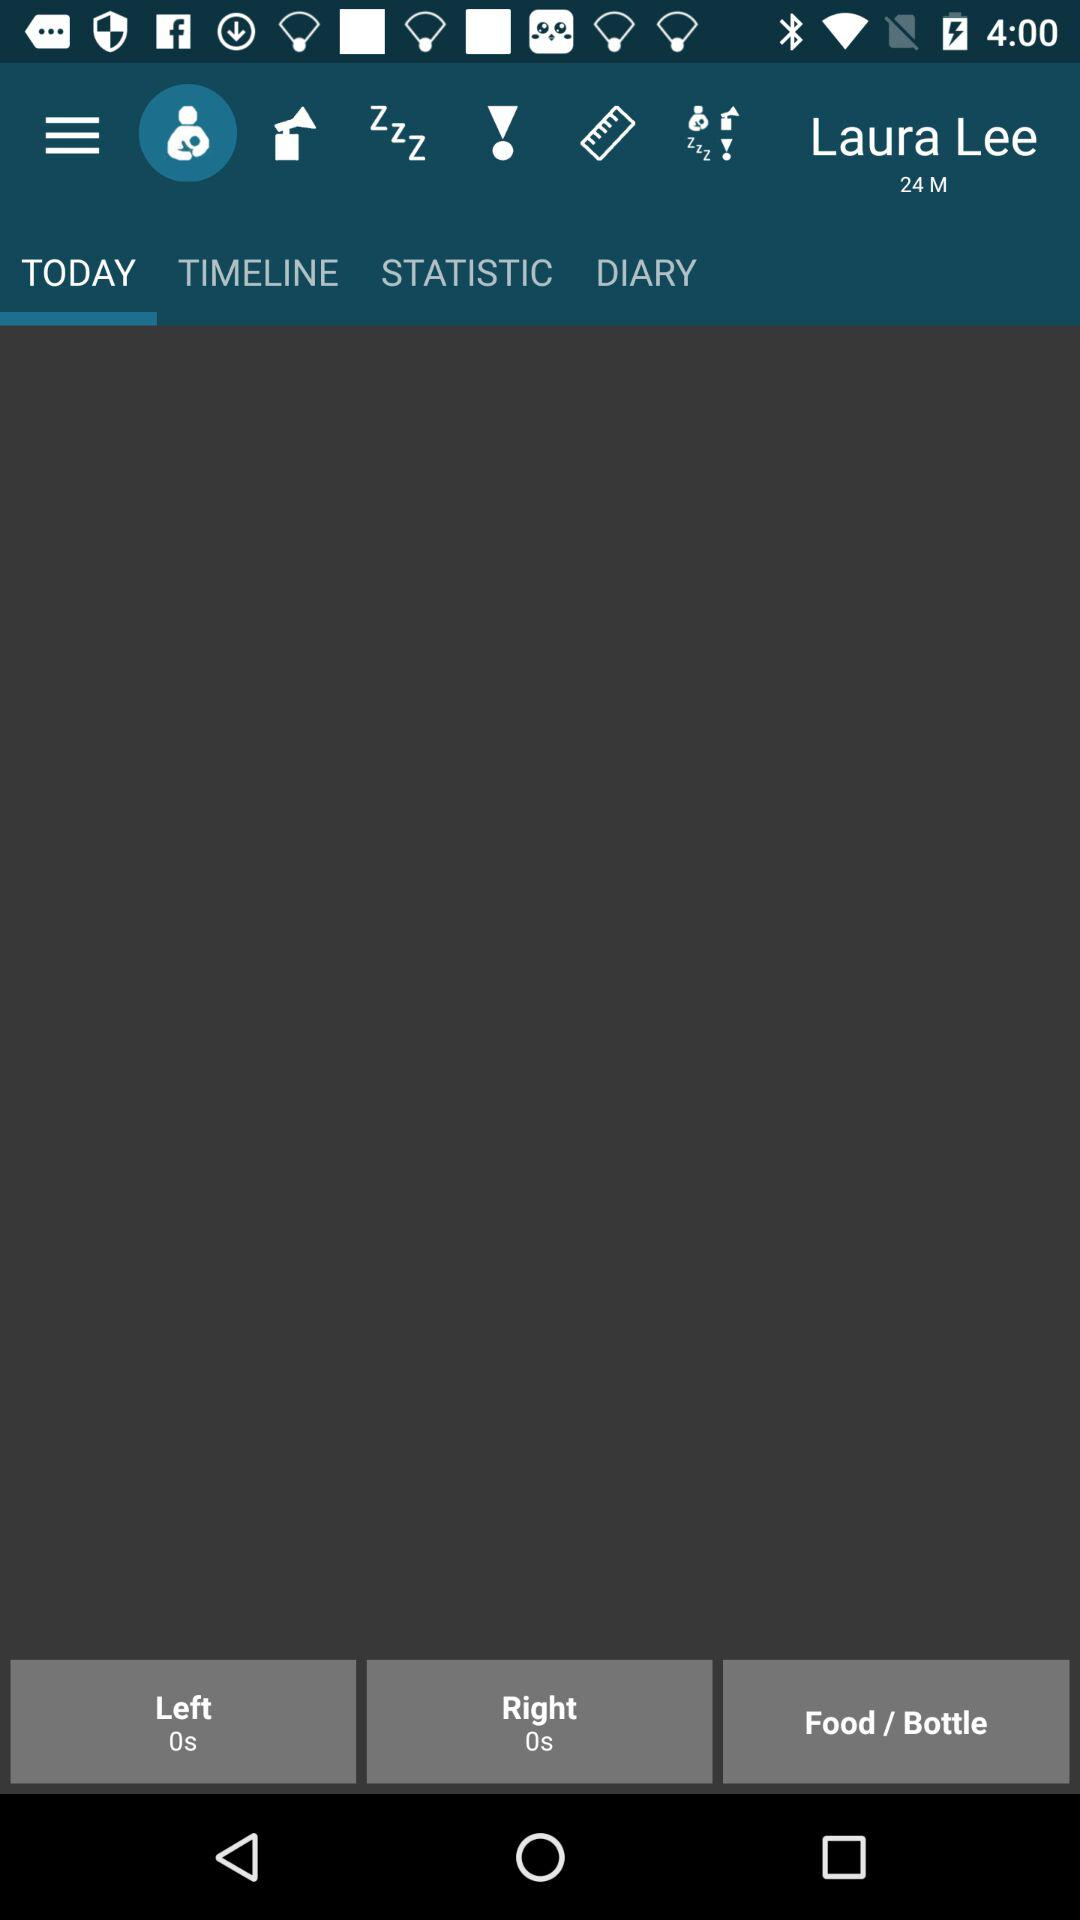What is the setting for left? The setting for left is 0 seconds. 